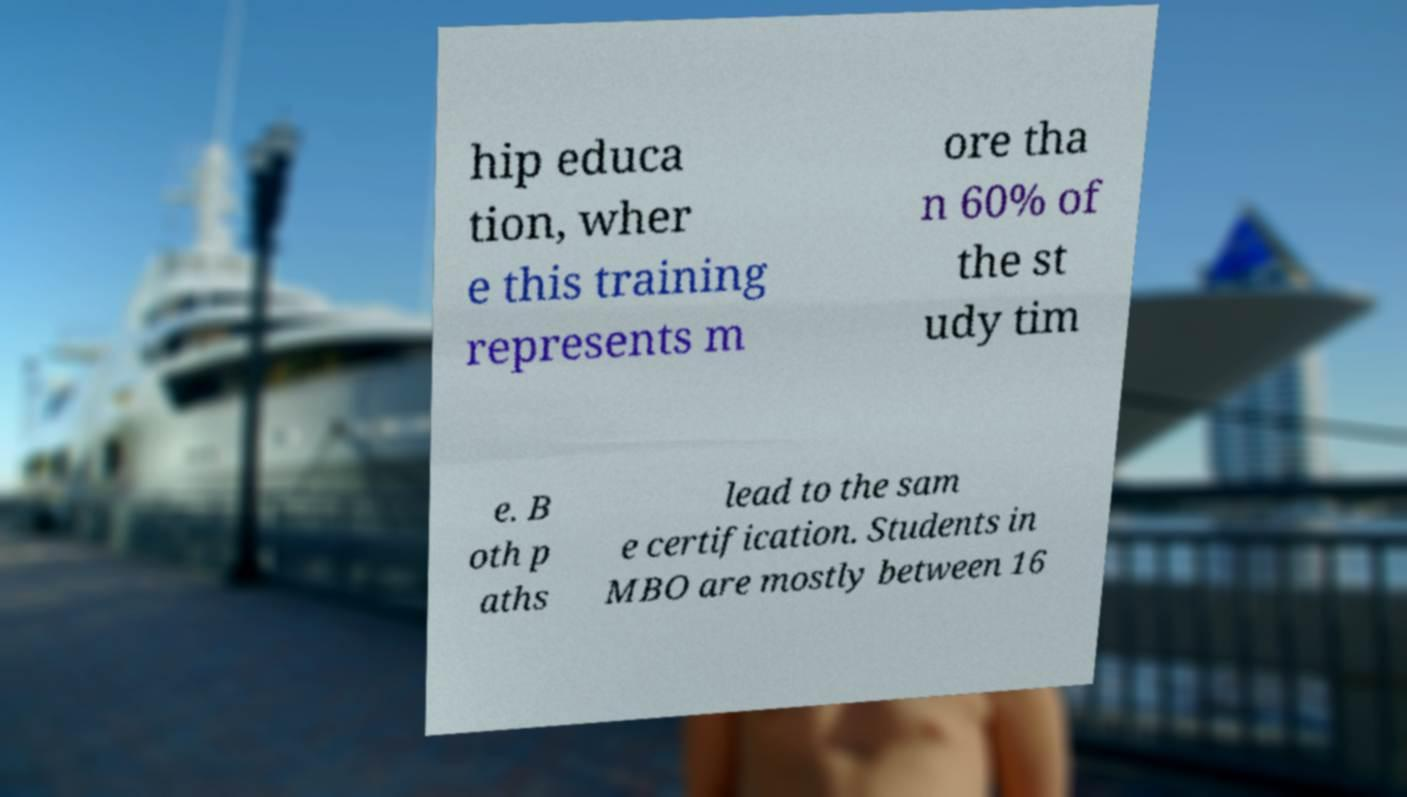Could you assist in decoding the text presented in this image and type it out clearly? hip educa tion, wher e this training represents m ore tha n 60% of the st udy tim e. B oth p aths lead to the sam e certification. Students in MBO are mostly between 16 